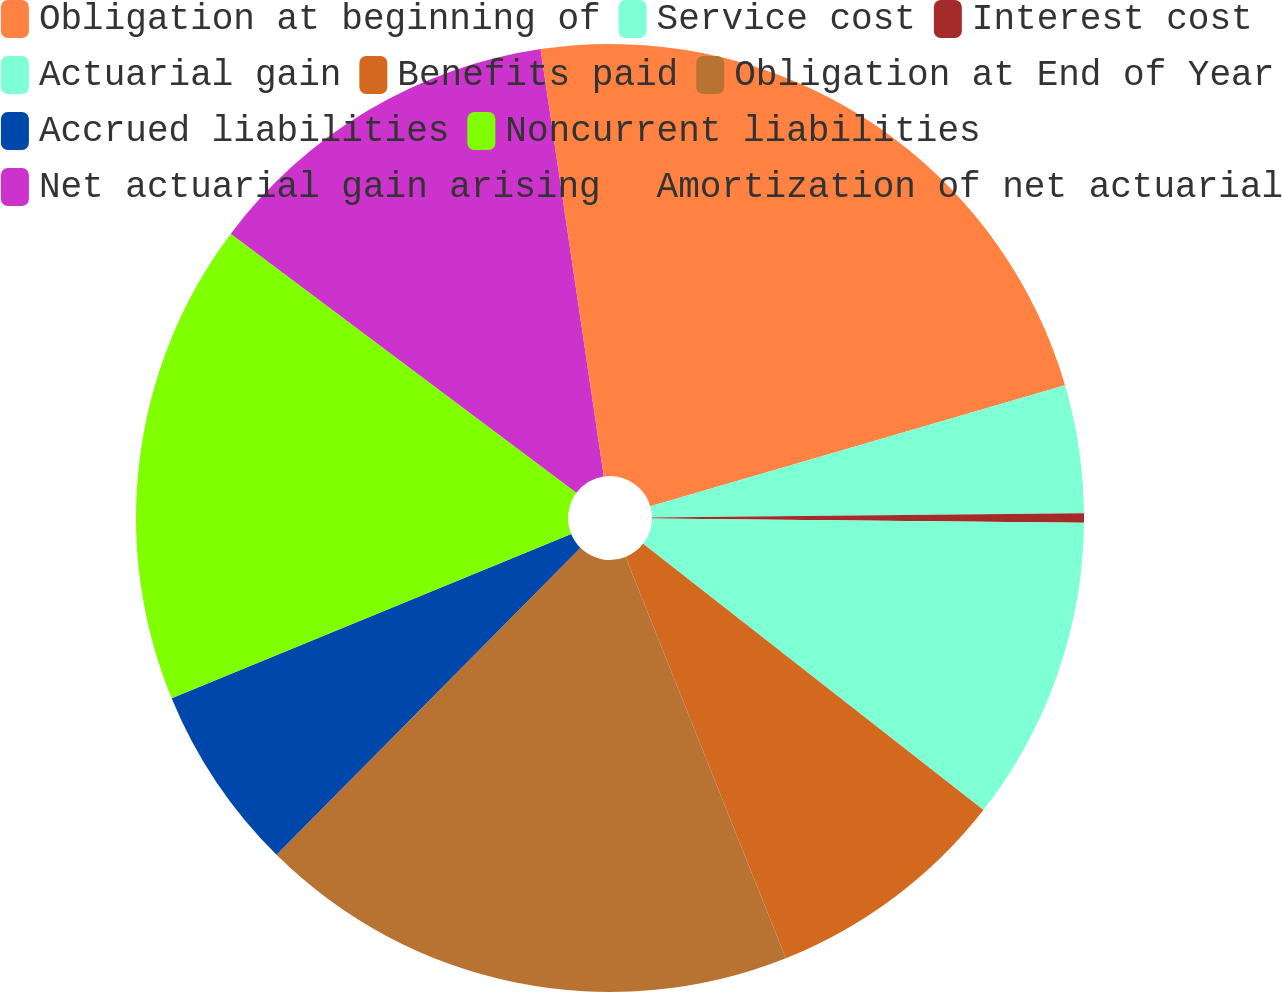<chart> <loc_0><loc_0><loc_500><loc_500><pie_chart><fcel>Obligation at beginning of<fcel>Service cost<fcel>Interest cost<fcel>Actuarial gain<fcel>Benefits paid<fcel>Obligation at End of Year<fcel>Accrued liabilities<fcel>Noncurrent liabilities<fcel>Net actuarial gain arising<fcel>Amortization of net actuarial<nl><fcel>20.48%<fcel>4.36%<fcel>0.32%<fcel>10.4%<fcel>8.39%<fcel>18.47%<fcel>6.37%<fcel>16.45%<fcel>12.42%<fcel>2.34%<nl></chart> 